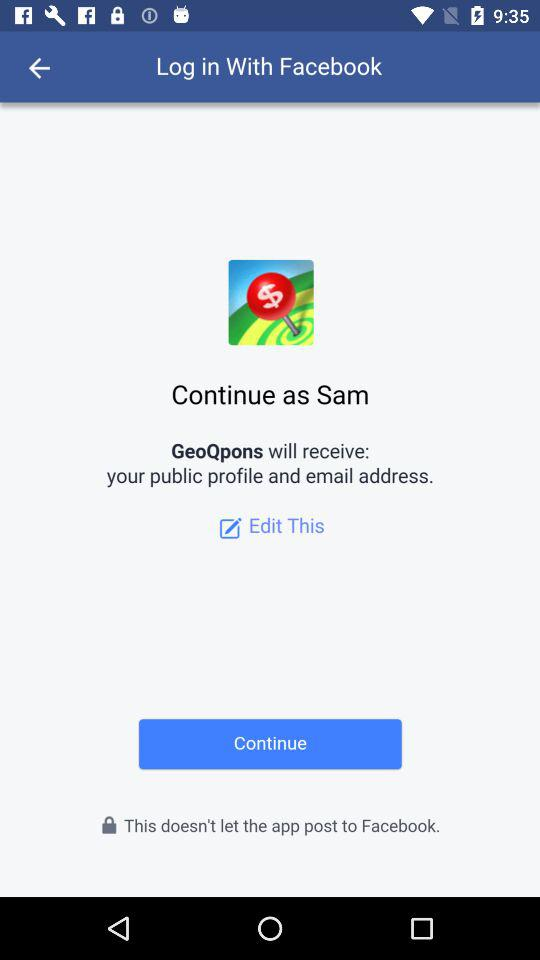What other application can use to log in to the profile?
When the provided information is insufficient, respond with <no answer>. <no answer> 